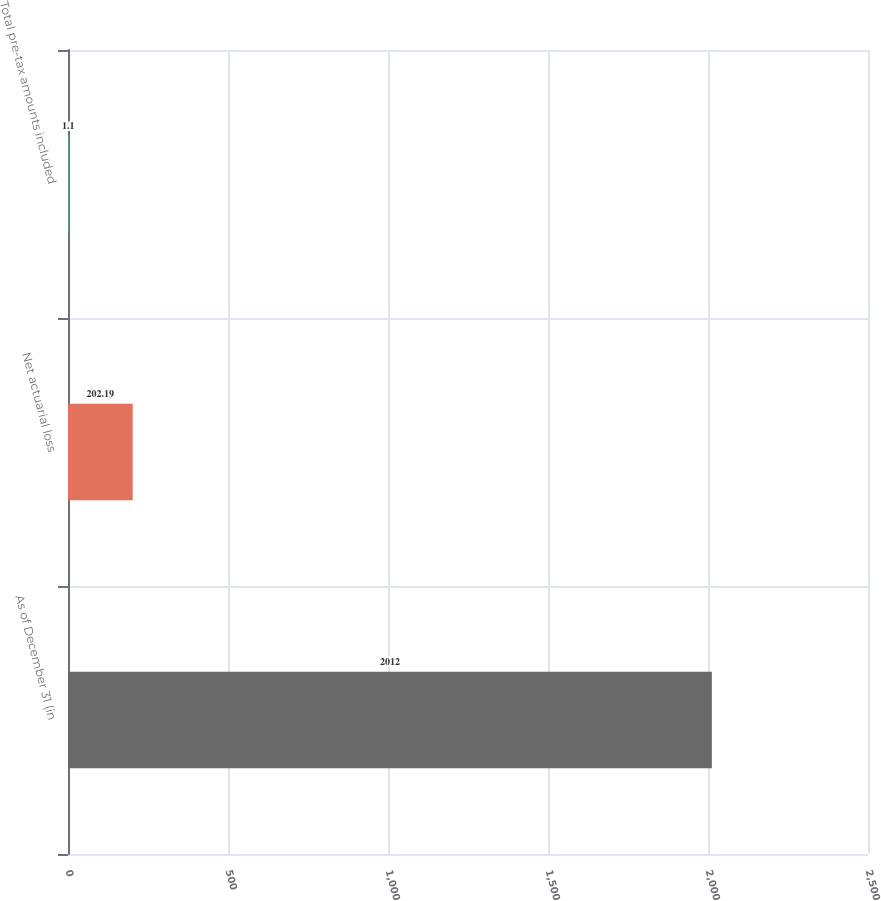Convert chart to OTSL. <chart><loc_0><loc_0><loc_500><loc_500><bar_chart><fcel>As of December 31 (in<fcel>Net actuarial loss<fcel>Total pre-tax amounts included<nl><fcel>2012<fcel>202.19<fcel>1.1<nl></chart> 